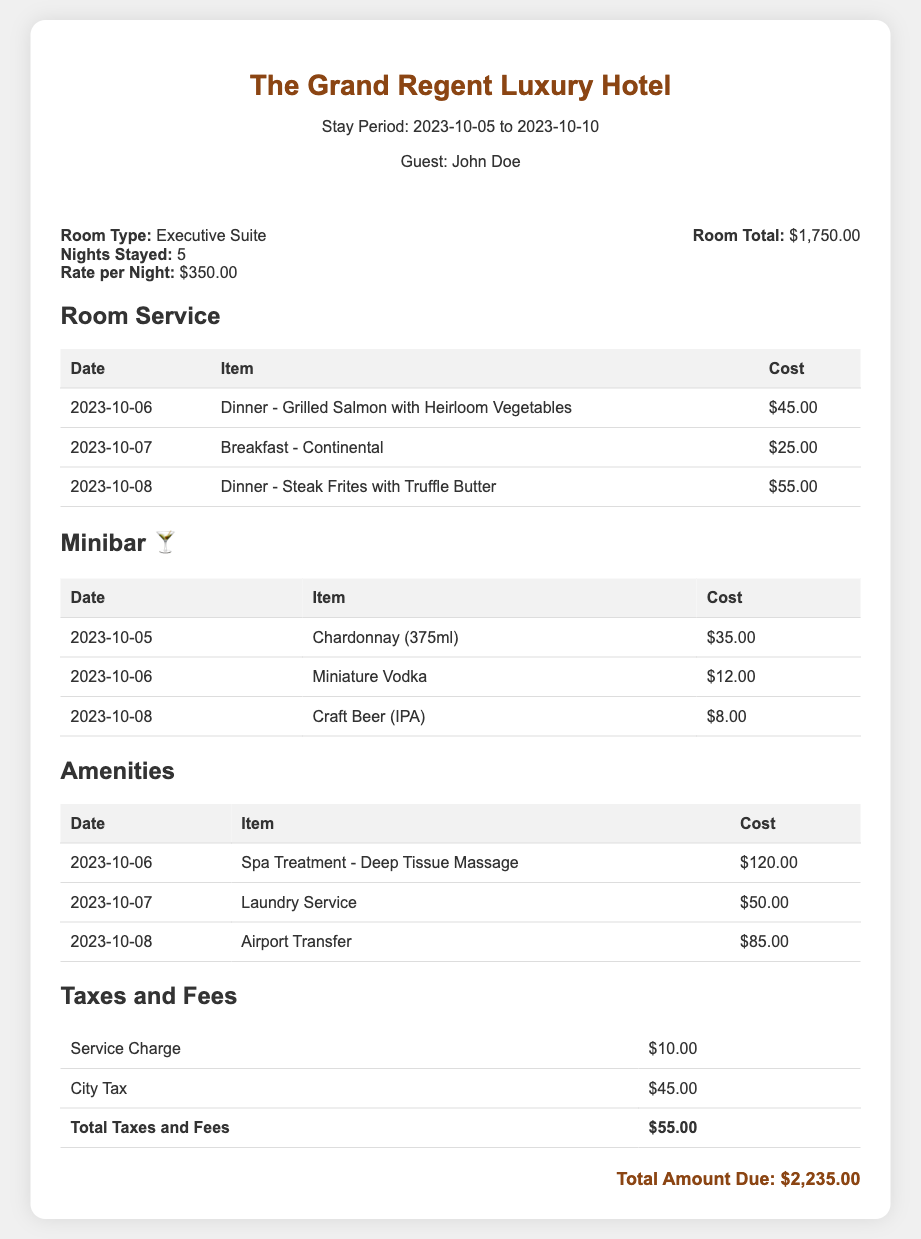What is the guest's name? The document clearly identifies the guest as John Doe.
Answer: John Doe How many nights did the guest stay? The document states that the guest stayed for 5 nights.
Answer: 5 What is the total charge for the room? The room total is provided as $1,750.00.
Answer: $1,750.00 What was the cost of the spa treatment? The document lists the cost of the spa treatment as $120.00.
Answer: $120.00 What item was charged on 2023-10-07 for room service? The document specifies that Breakfast - Continental was ordered on this date.
Answer: Breakfast - Continental What was the total amount due? The total amount due at the end of the document is $2,235.00.
Answer: $2,235.00 What type of room did the guest book? The document indicates that the guest booked an Executive Suite.
Answer: Executive Suite What is the cost of the city tax? The document mentions that the city tax is $45.00.
Answer: $45.00 How much did the guest spend on minibar items in total? By adding the individual minibar charges, the total is $55.00 ($35.00 + $12.00 + $8.00).
Answer: $55.00 